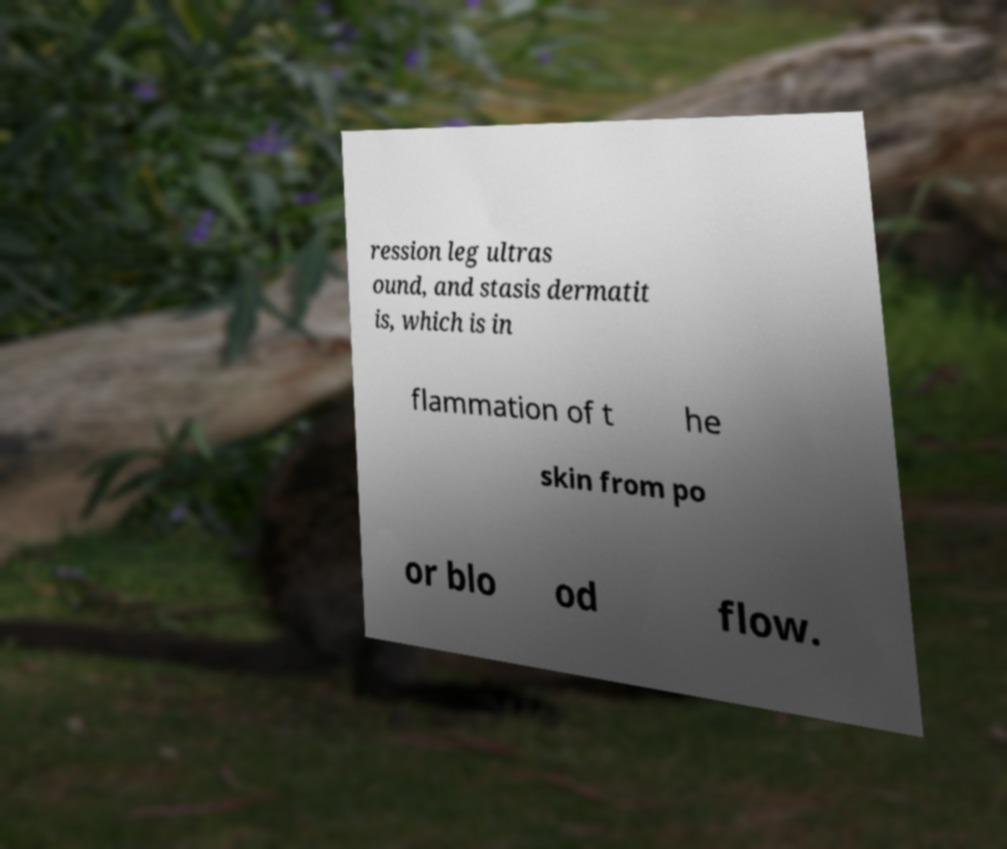Please identify and transcribe the text found in this image. ression leg ultras ound, and stasis dermatit is, which is in flammation of t he skin from po or blo od flow. 